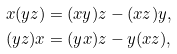Convert formula to latex. <formula><loc_0><loc_0><loc_500><loc_500>x ( y z ) & = ( x y ) z - ( x z ) y , \\ ( y z ) x & = ( y x ) z - y ( x z ) ,</formula> 